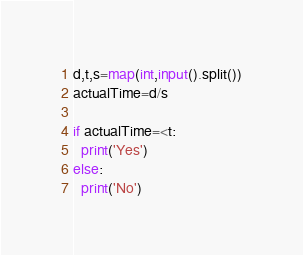Convert code to text. <code><loc_0><loc_0><loc_500><loc_500><_Python_>d,t,s=map(int,input().split())
actualTime=d/s
 
if actualTime=<t:
  print('Yes')
else:
  print('No')</code> 